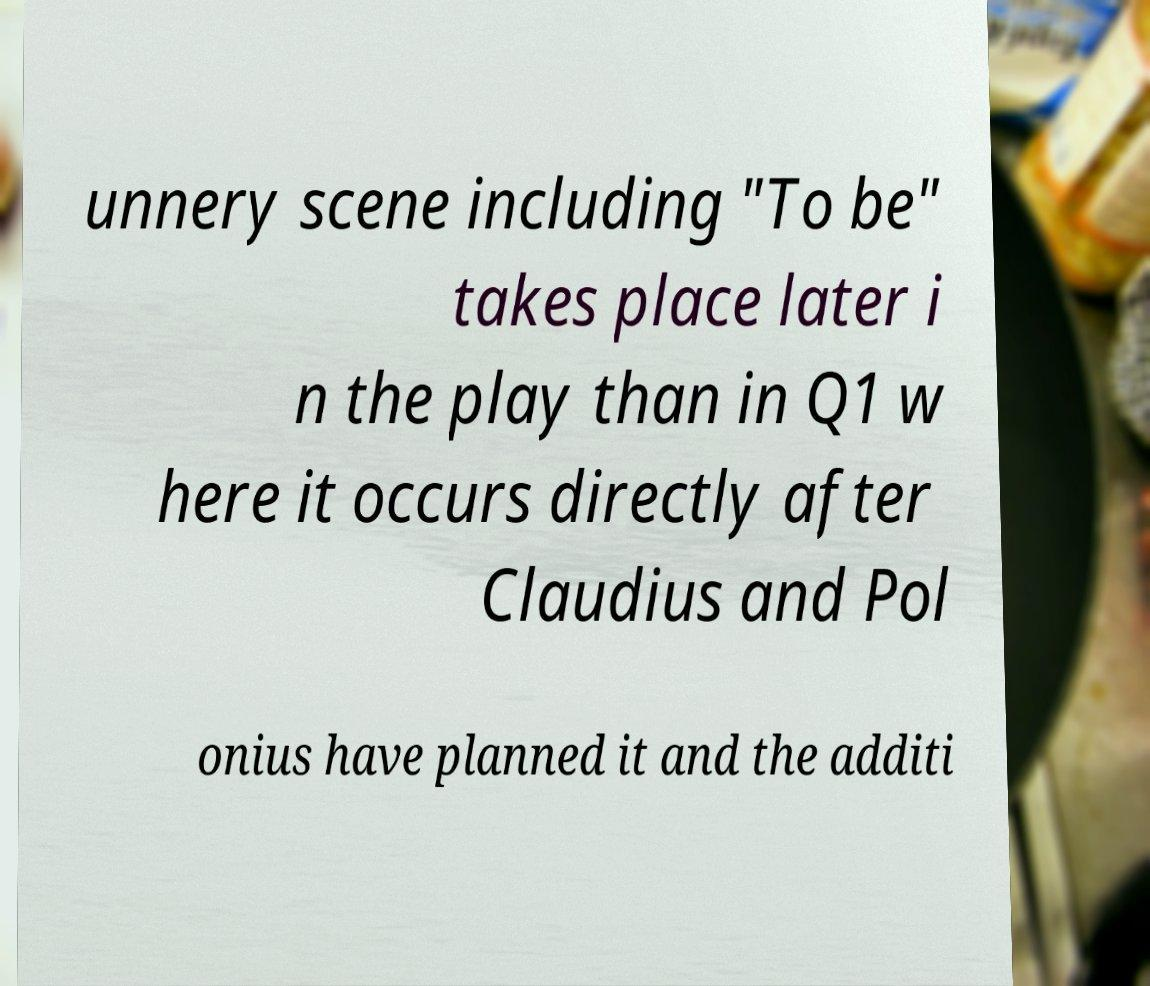Please identify and transcribe the text found in this image. unnery scene including "To be" takes place later i n the play than in Q1 w here it occurs directly after Claudius and Pol onius have planned it and the additi 